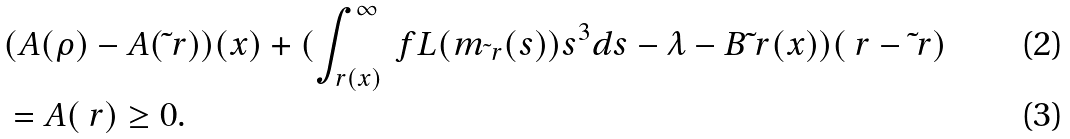<formula> <loc_0><loc_0><loc_500><loc_500>& ( A ( \rho ) - A ( \tilde { \ } r ) ) ( x ) + ( \int _ { r ( x ) } ^ { \infty } \ f { L ( m _ { \tilde { \ } r } ( s ) ) } { s ^ { 3 } } d s - \lambda - B \tilde { \ } r ( x ) ) ( \ r - \tilde { \ } r ) \\ & = A ( \ r ) \geq 0 .</formula> 